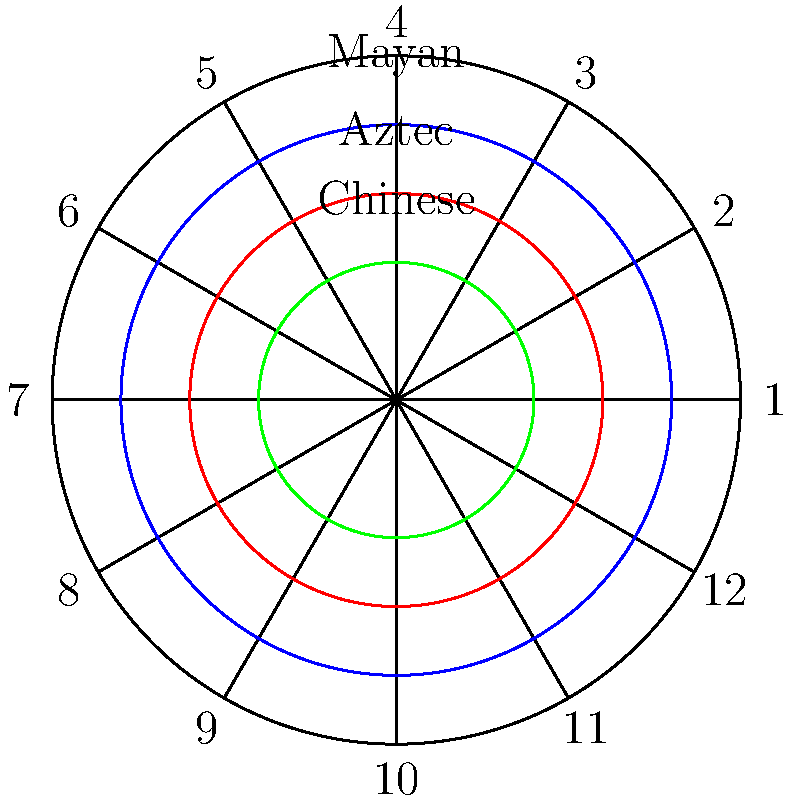In the circular calendar representation above, which culture's time measurement system is represented by the innermost circle, and what astronomical phenomenon is it most likely based on? To answer this question, let's analyze the circular calendar representation step-by-step:

1. The diagram shows three concentric circles within a larger circle divided into 12 sections.

2. Each circle is labeled with a different culture:
   - Outermost (blue): Mayan
   - Middle (red): Aztec
   - Innermost (green): Chinese

3. The question asks about the innermost circle, which represents the Chinese time measurement system.

4. Chinese calendars are traditionally based on lunar cycles, unlike solar-based calendars common in Western cultures.

5. The lunar cycle, or synodic month, is approximately 29.5 days long, which closely matches the time it takes for the Moon to complete its phases.

6. The Chinese calendar uses a system of 12 lunar months, with an occasional 13th month added to keep it aligned with the solar year.

7. This 12-month structure is reflected in the 12 divisions of the outer circle in the diagram.

Therefore, the Chinese time measurement system represented by the innermost circle is most likely based on the lunar cycle.
Answer: Chinese; lunar cycle 